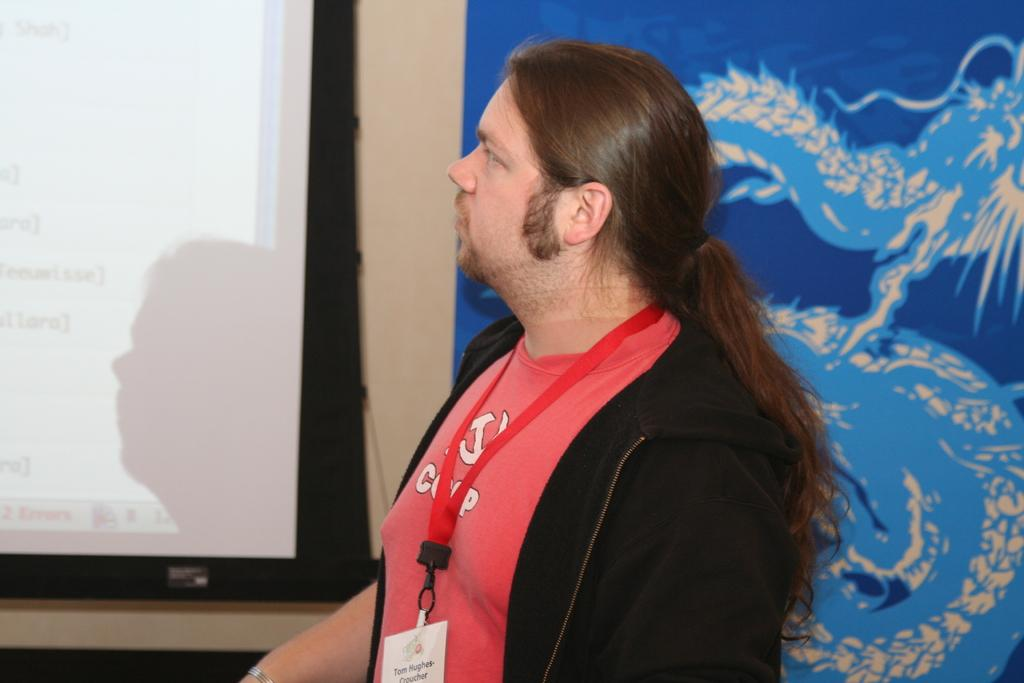Who is present in the image? There is a person in the image. What is the person wearing that is visible in the image? The person is wearing an ID card. What can be seen in the background of the image? There is a screen and a poster in the background of the image. What type of cord is being used to paint on the canvas in the image? There is no cord or canvas present in the image. What type of paper is the person holding in the image? There is no paper visible in the image. 